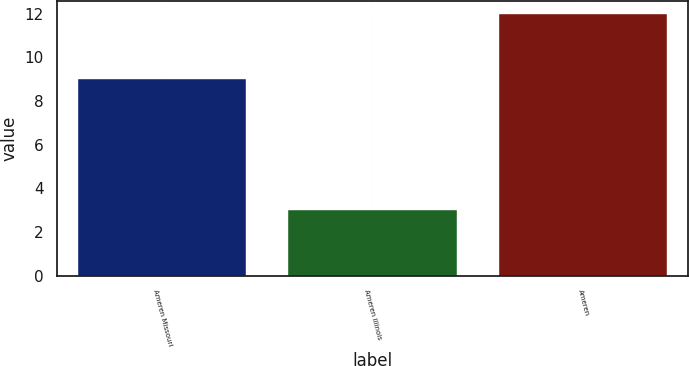Convert chart. <chart><loc_0><loc_0><loc_500><loc_500><bar_chart><fcel>Ameren Missouri<fcel>Ameren Illinois<fcel>Ameren<nl><fcel>9<fcel>3<fcel>12<nl></chart> 